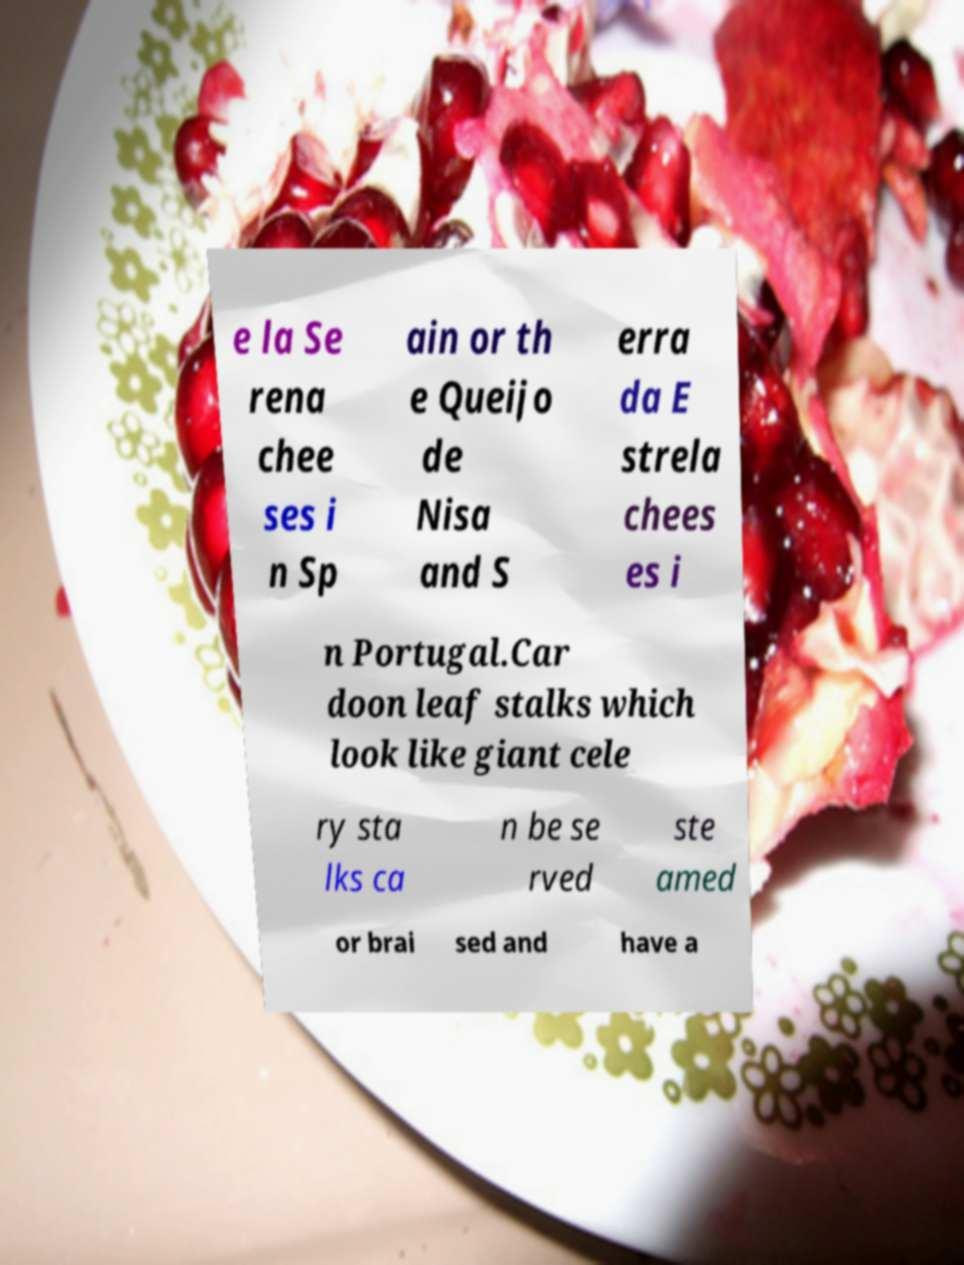There's text embedded in this image that I need extracted. Can you transcribe it verbatim? e la Se rena chee ses i n Sp ain or th e Queijo de Nisa and S erra da E strela chees es i n Portugal.Car doon leaf stalks which look like giant cele ry sta lks ca n be se rved ste amed or brai sed and have a 